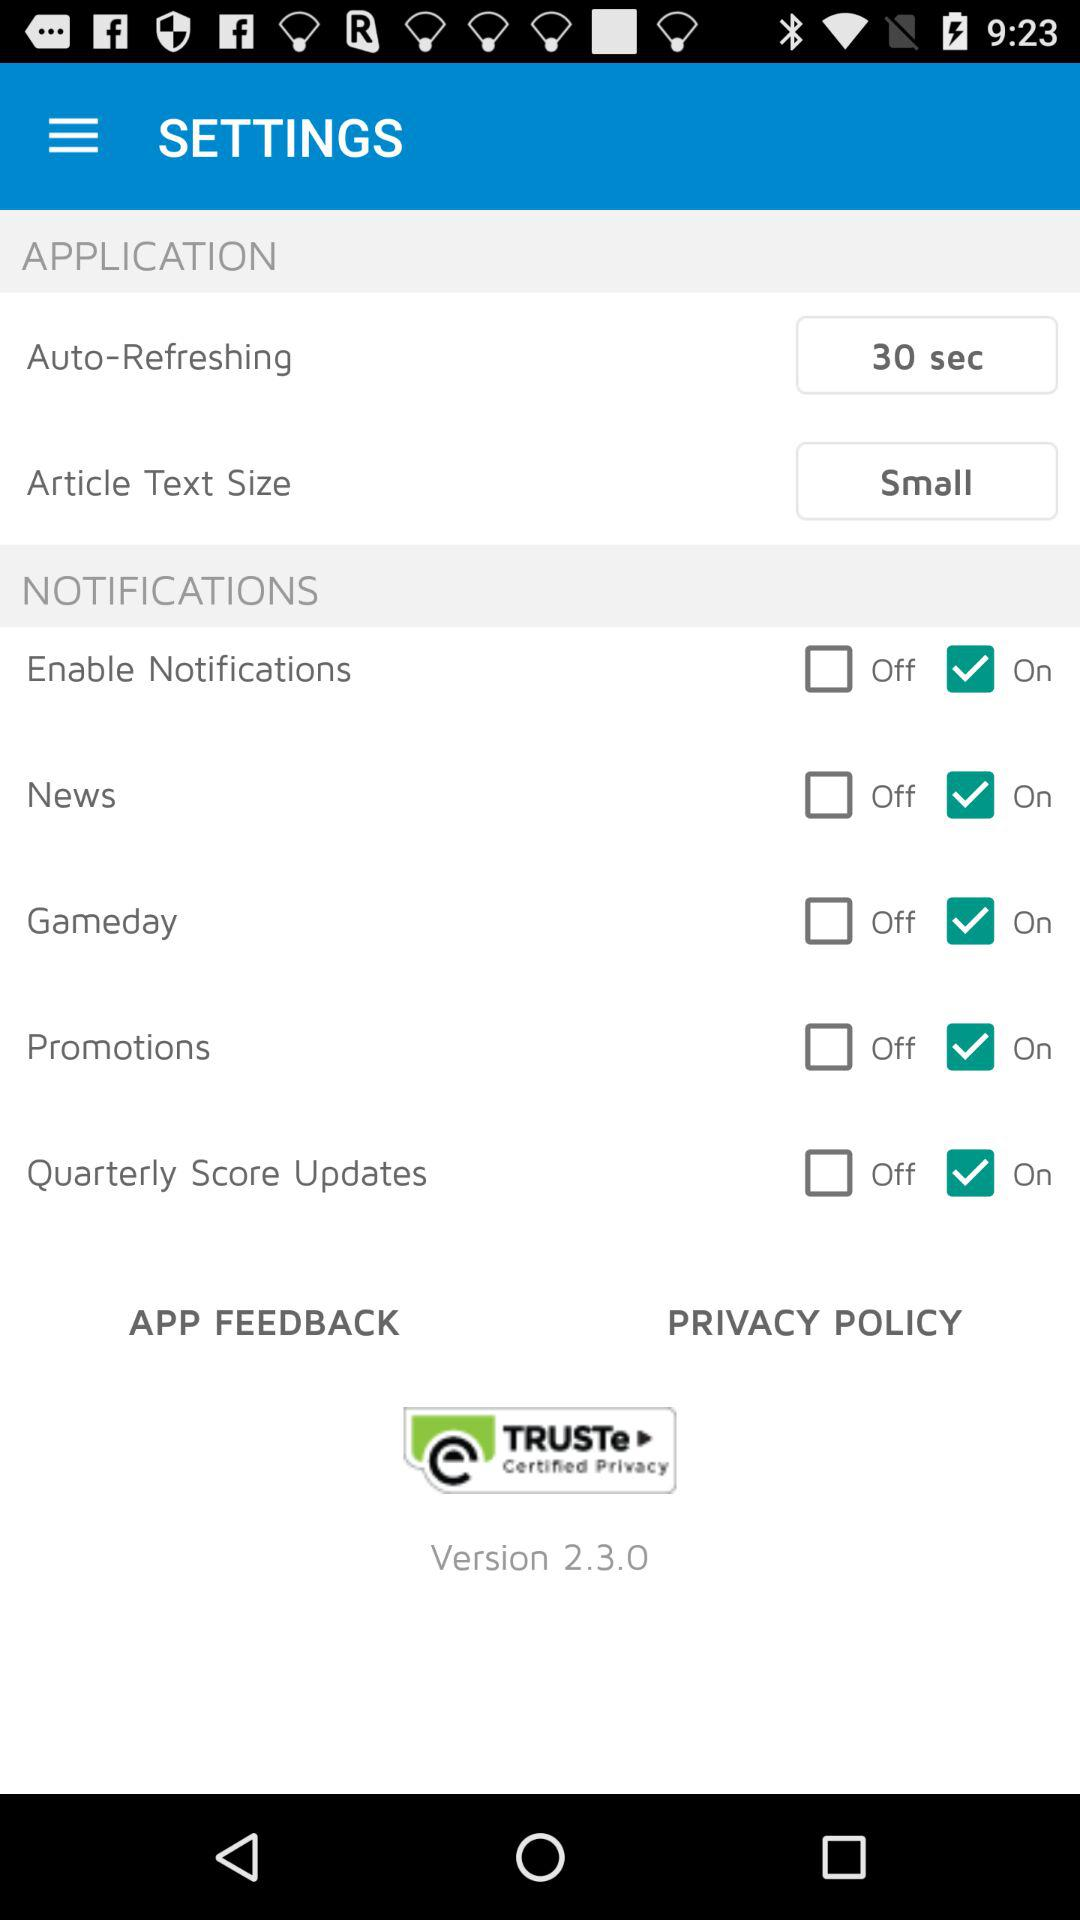What is the status of the "News"? The status is "on". 